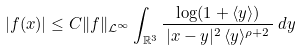<formula> <loc_0><loc_0><loc_500><loc_500>| f ( x ) | \leq C \| f \| _ { { \mathcal { L } } ^ { \infty } } \int _ { { \mathbb { R } } ^ { 3 } } \frac { \log ( 1 + \langle y \rangle ) } { \, | x - y | ^ { 2 } \, \langle y \rangle ^ { \rho + 2 } \, } \, d y</formula> 